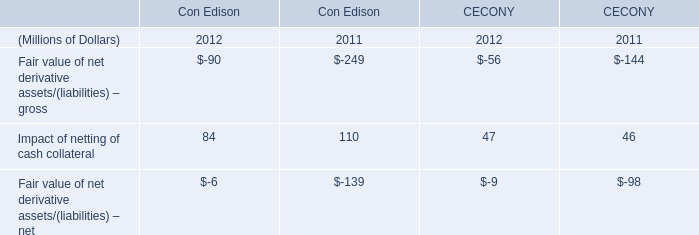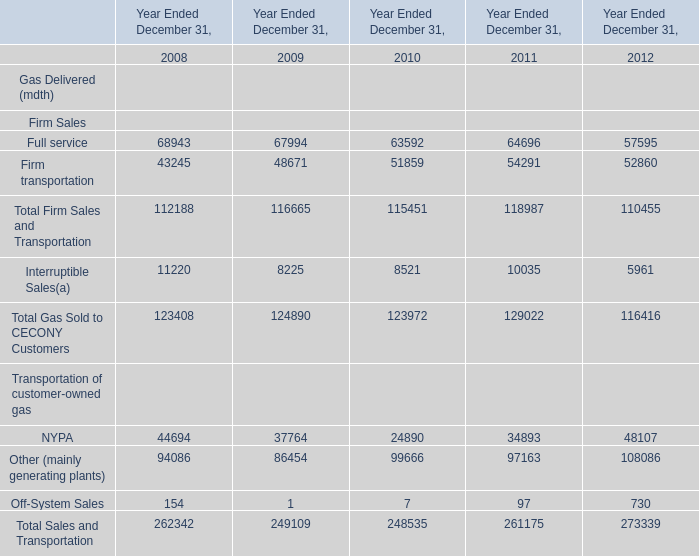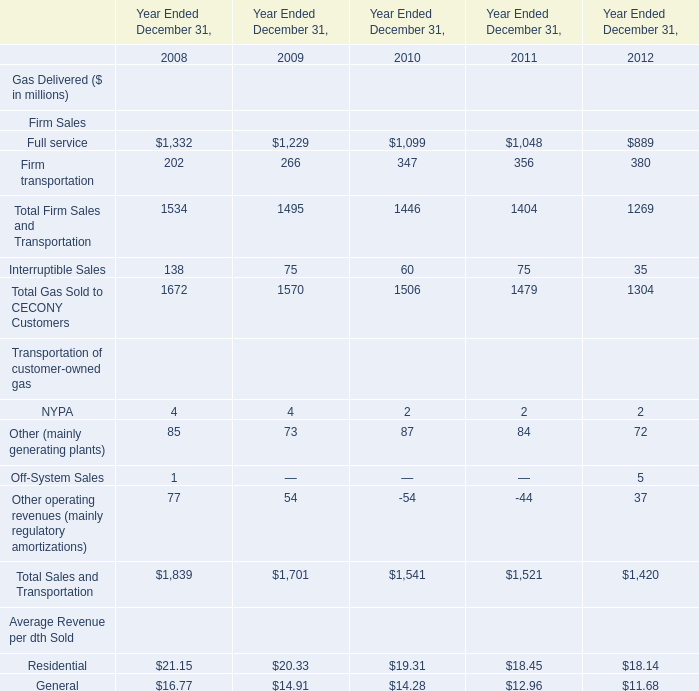What was the total amount of NYPA,Other (mainly generating plants), Off-System Sales and Other operating revenues (mainly regulatory amortizations) in 2008? (in million) 
Computations: (((4 + 85) + 1) + 77)
Answer: 167.0. 